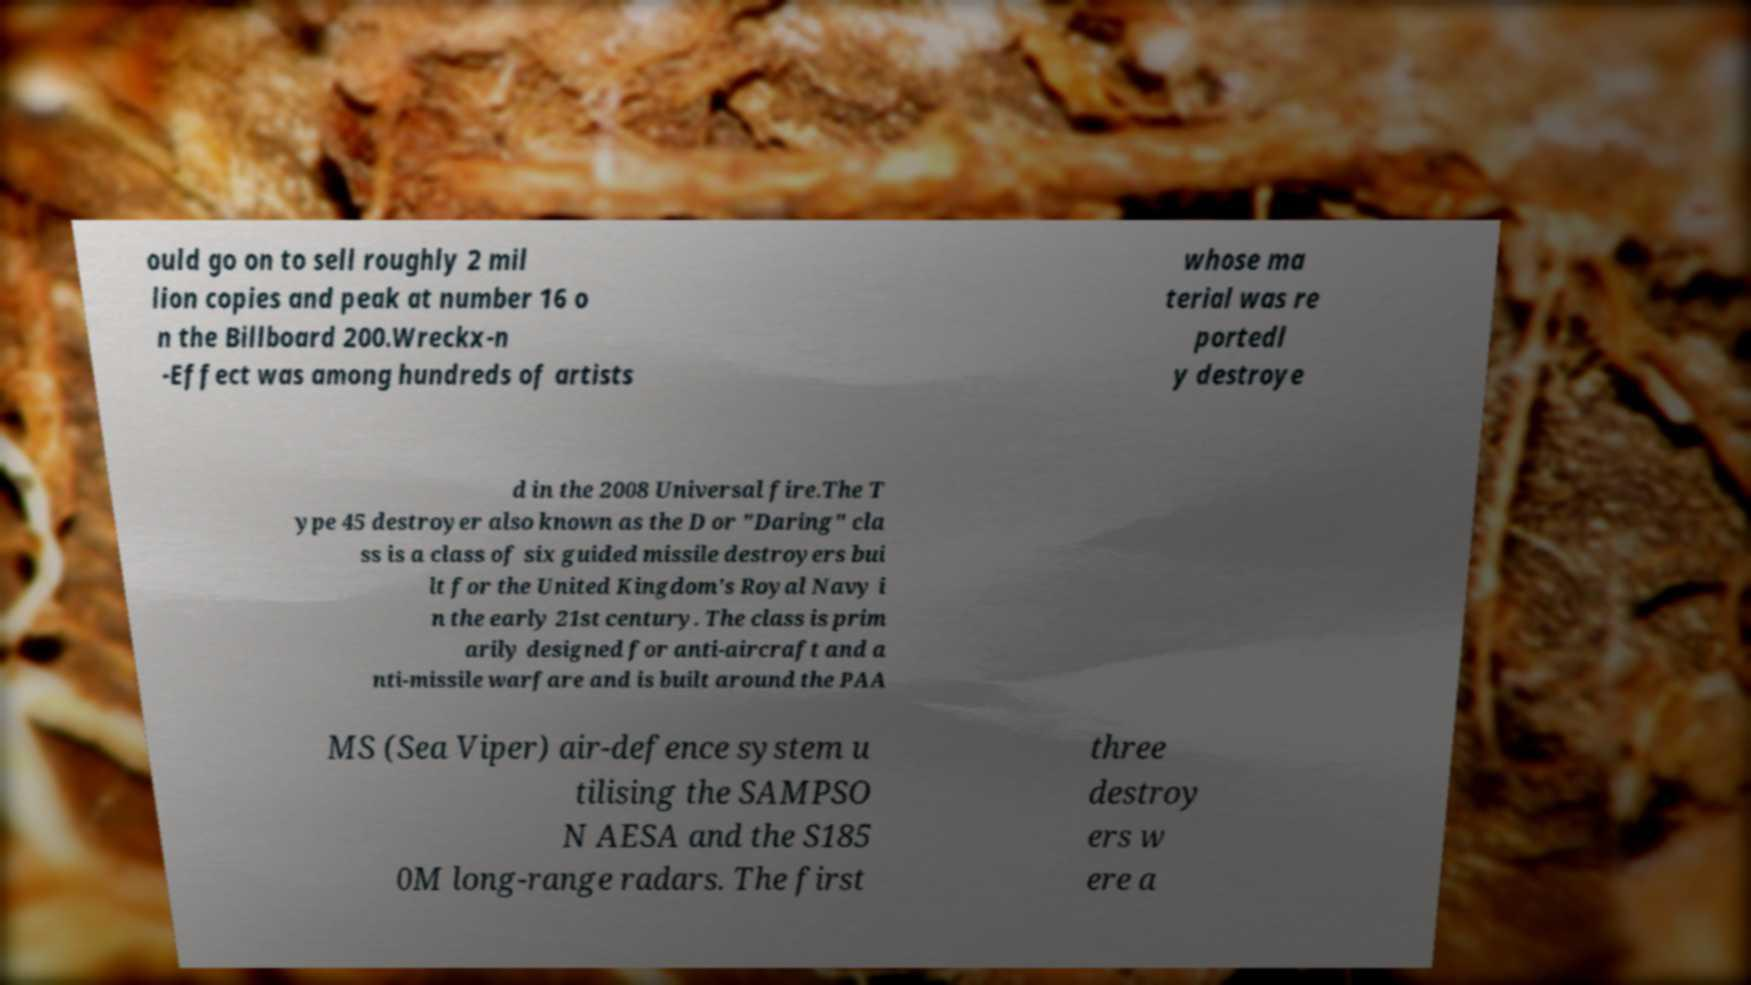Please read and relay the text visible in this image. What does it say? ould go on to sell roughly 2 mil lion copies and peak at number 16 o n the Billboard 200.Wreckx-n -Effect was among hundreds of artists whose ma terial was re portedl y destroye d in the 2008 Universal fire.The T ype 45 destroyer also known as the D or "Daring" cla ss is a class of six guided missile destroyers bui lt for the United Kingdom's Royal Navy i n the early 21st century. The class is prim arily designed for anti-aircraft and a nti-missile warfare and is built around the PAA MS (Sea Viper) air-defence system u tilising the SAMPSO N AESA and the S185 0M long-range radars. The first three destroy ers w ere a 